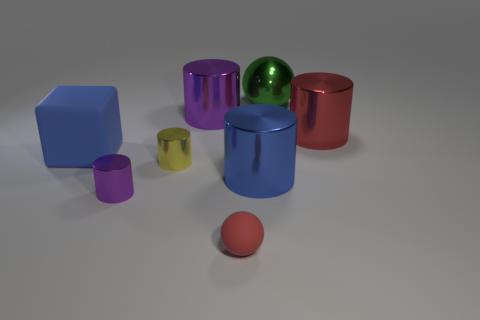Subtract all tiny yellow metal cylinders. How many cylinders are left? 4 Add 2 large red objects. How many objects exist? 10 Subtract all red balls. How many balls are left? 1 Subtract 3 cylinders. How many cylinders are left? 2 Subtract all blue cylinders. How many green balls are left? 1 Subtract all spheres. How many objects are left? 6 Subtract all purple cubes. Subtract all purple cylinders. How many cubes are left? 1 Subtract all rubber blocks. Subtract all blocks. How many objects are left? 6 Add 4 large rubber blocks. How many large rubber blocks are left? 5 Add 2 yellow objects. How many yellow objects exist? 3 